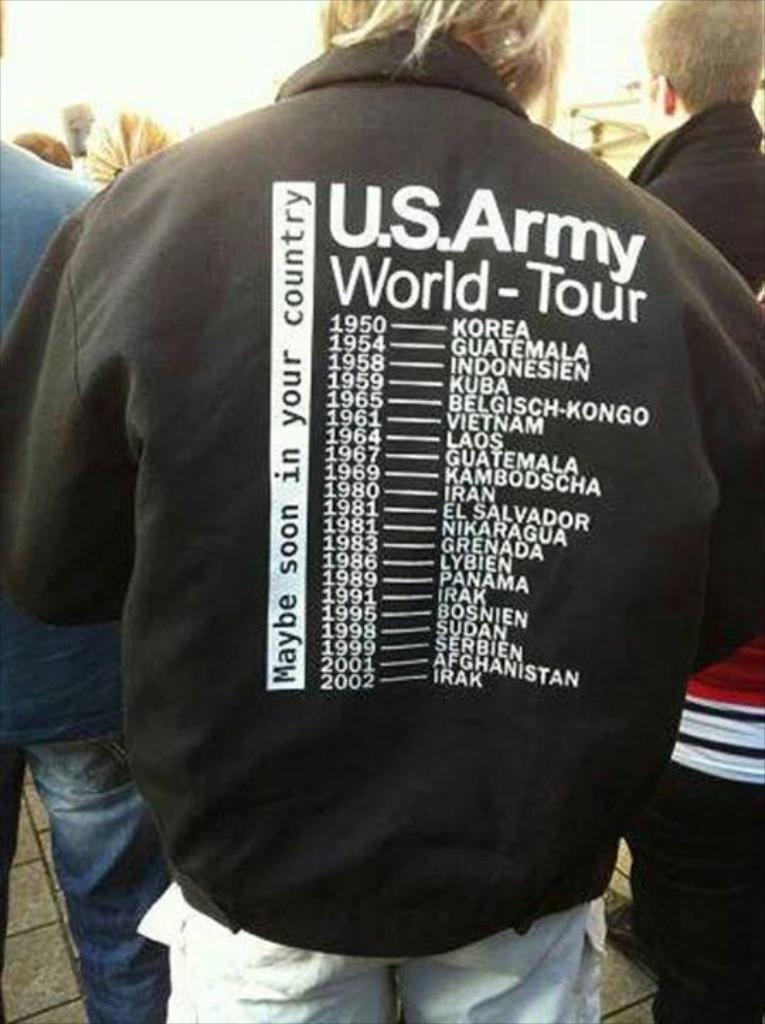Please provide a concise description of this image. As we can see in the image there are few people here and there. The man in the front is wearing black color jacket and at the top there is a sky. 